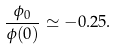Convert formula to latex. <formula><loc_0><loc_0><loc_500><loc_500>\frac { \phi _ { 0 } } { \phi ( 0 ) } \simeq - 0 . 2 5 .</formula> 